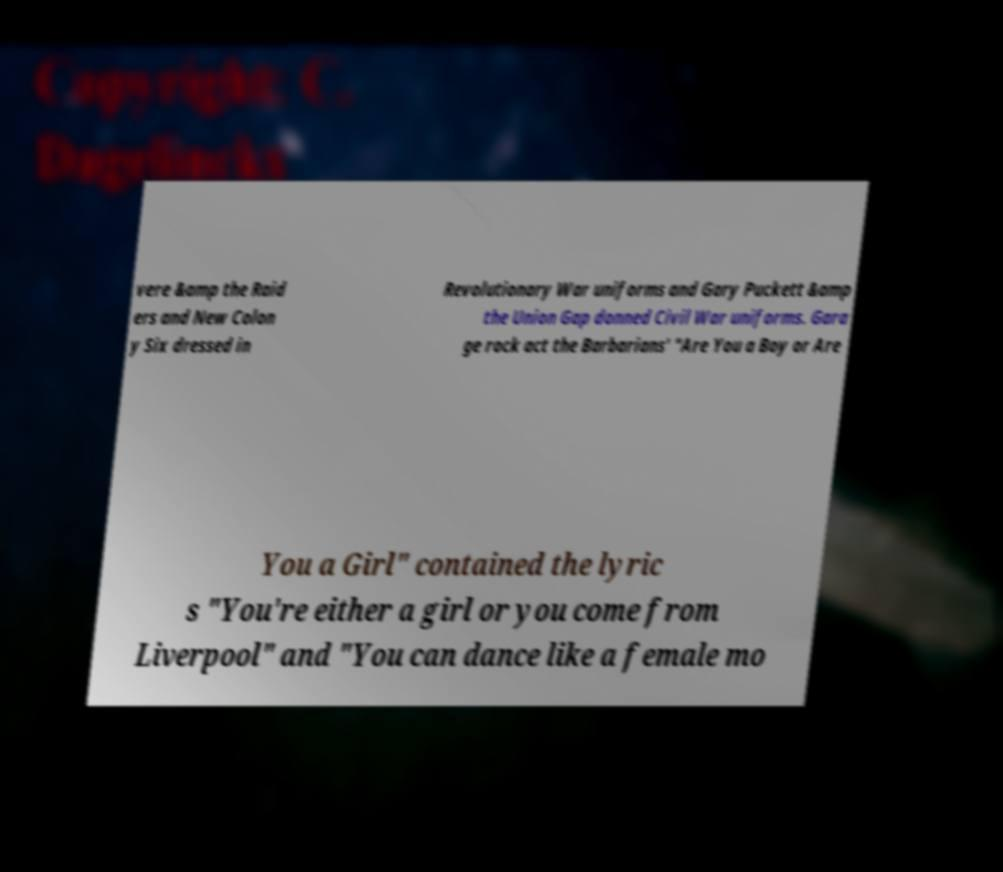Please read and relay the text visible in this image. What does it say? vere &amp the Raid ers and New Colon y Six dressed in Revolutionary War uniforms and Gary Puckett &amp the Union Gap donned Civil War uniforms. Gara ge rock act the Barbarians' "Are You a Boy or Are You a Girl" contained the lyric s "You're either a girl or you come from Liverpool" and "You can dance like a female mo 